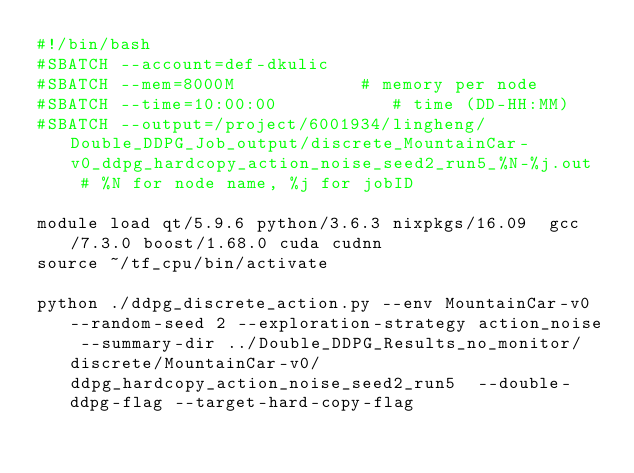Convert code to text. <code><loc_0><loc_0><loc_500><loc_500><_Bash_>#!/bin/bash
#SBATCH --account=def-dkulic
#SBATCH --mem=8000M            # memory per node
#SBATCH --time=10:00:00           # time (DD-HH:MM)
#SBATCH --output=/project/6001934/lingheng/Double_DDPG_Job_output/discrete_MountainCar-v0_ddpg_hardcopy_action_noise_seed2_run5_%N-%j.out  # %N for node name, %j for jobID

module load qt/5.9.6 python/3.6.3 nixpkgs/16.09  gcc/7.3.0 boost/1.68.0 cuda cudnn
source ~/tf_cpu/bin/activate

python ./ddpg_discrete_action.py --env MountainCar-v0 --random-seed 2 --exploration-strategy action_noise --summary-dir ../Double_DDPG_Results_no_monitor/discrete/MountainCar-v0/ddpg_hardcopy_action_noise_seed2_run5  --double-ddpg-flag --target-hard-copy-flag 

</code> 